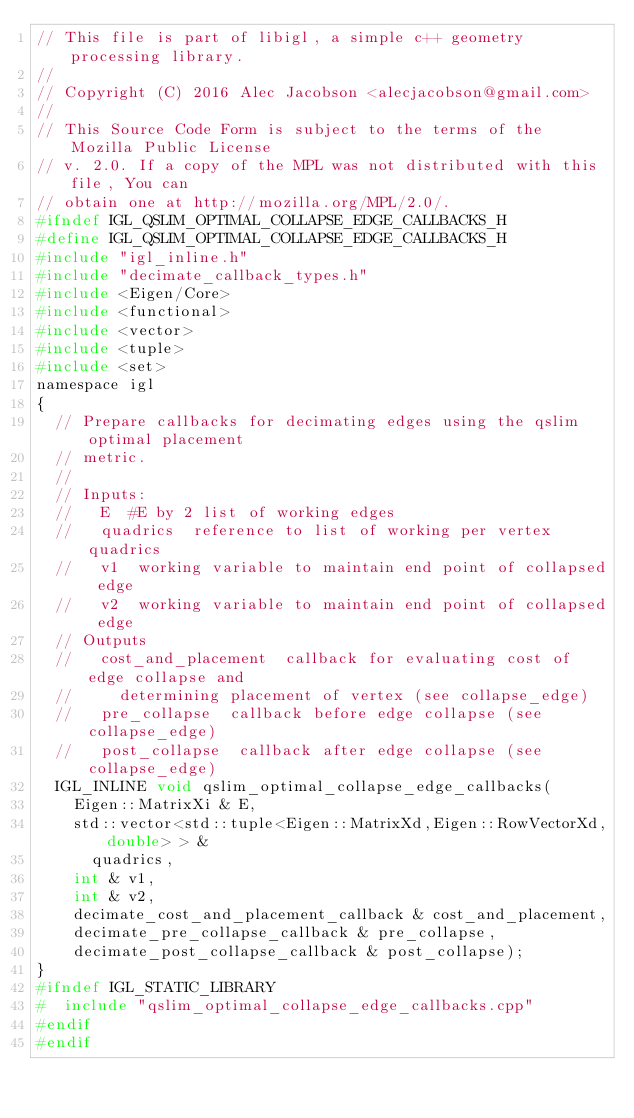<code> <loc_0><loc_0><loc_500><loc_500><_C_>// This file is part of libigl, a simple c++ geometry processing library.
// 
// Copyright (C) 2016 Alec Jacobson <alecjacobson@gmail.com>
// 
// This Source Code Form is subject to the terms of the Mozilla Public License 
// v. 2.0. If a copy of the MPL was not distributed with this file, You can 
// obtain one at http://mozilla.org/MPL/2.0/.
#ifndef IGL_QSLIM_OPTIMAL_COLLAPSE_EDGE_CALLBACKS_H
#define IGL_QSLIM_OPTIMAL_COLLAPSE_EDGE_CALLBACKS_H
#include "igl_inline.h"
#include "decimate_callback_types.h"
#include <Eigen/Core>
#include <functional>
#include <vector>
#include <tuple>
#include <set>
namespace igl
{
  // Prepare callbacks for decimating edges using the qslim optimal placement
  // metric.
  //
  // Inputs:
  //   E  #E by 2 list of working edges
  //   quadrics  reference to list of working per vertex quadrics 
  //   v1  working variable to maintain end point of collapsed edge
  //   v2  working variable to maintain end point of collapsed edge
  // Outputs
  //   cost_and_placement  callback for evaluating cost of edge collapse and
  //     determining placement of vertex (see collapse_edge)
  //   pre_collapse  callback before edge collapse (see collapse_edge)
  //   post_collapse  callback after edge collapse (see collapse_edge)
  IGL_INLINE void qslim_optimal_collapse_edge_callbacks(
    Eigen::MatrixXi & E,
    std::vector<std::tuple<Eigen::MatrixXd,Eigen::RowVectorXd,double> > & 
      quadrics,
    int & v1,
    int & v2,
    decimate_cost_and_placement_callback & cost_and_placement,
    decimate_pre_collapse_callback & pre_collapse,
    decimate_post_collapse_callback & post_collapse);
}
#ifndef IGL_STATIC_LIBRARY
#  include "qslim_optimal_collapse_edge_callbacks.cpp"
#endif
#endif
</code> 